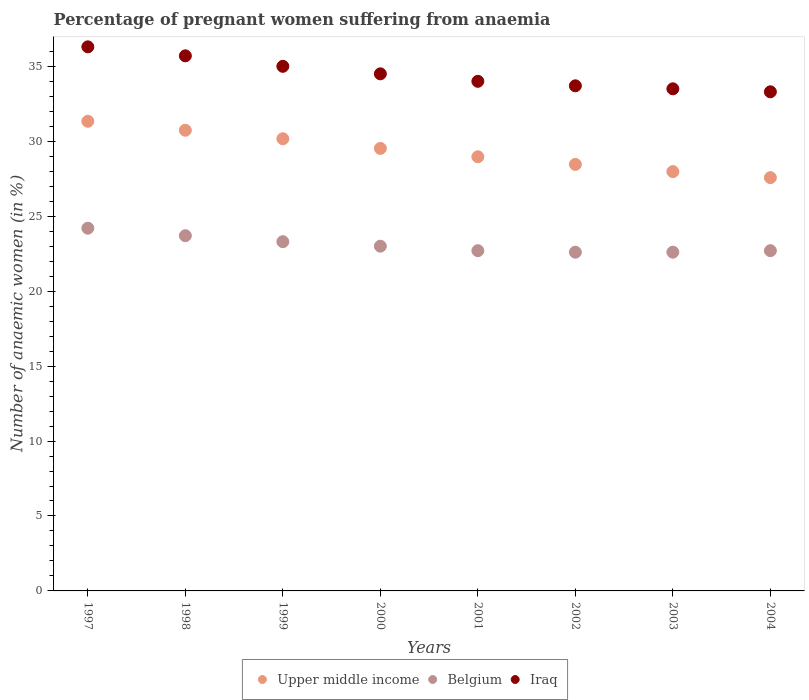How many different coloured dotlines are there?
Your response must be concise. 3. What is the number of anaemic women in Iraq in 2002?
Offer a terse response. 33.7. Across all years, what is the maximum number of anaemic women in Iraq?
Ensure brevity in your answer.  36.3. Across all years, what is the minimum number of anaemic women in Belgium?
Your answer should be very brief. 22.6. In which year was the number of anaemic women in Iraq maximum?
Make the answer very short. 1997. In which year was the number of anaemic women in Iraq minimum?
Ensure brevity in your answer.  2004. What is the total number of anaemic women in Upper middle income in the graph?
Provide a succinct answer. 234.73. What is the difference between the number of anaemic women in Belgium in 1999 and that in 2000?
Provide a short and direct response. 0.3. What is the difference between the number of anaemic women in Belgium in 2000 and the number of anaemic women in Iraq in 2001?
Your answer should be very brief. -11. What is the average number of anaemic women in Belgium per year?
Your answer should be very brief. 23.1. In how many years, is the number of anaemic women in Iraq greater than 1 %?
Keep it short and to the point. 8. What is the ratio of the number of anaemic women in Iraq in 1998 to that in 2002?
Your answer should be very brief. 1.06. Is the number of anaemic women in Iraq in 1999 less than that in 2000?
Keep it short and to the point. No. What is the difference between the highest and the second highest number of anaemic women in Iraq?
Make the answer very short. 0.6. In how many years, is the number of anaemic women in Belgium greater than the average number of anaemic women in Belgium taken over all years?
Ensure brevity in your answer.  3. Is the sum of the number of anaemic women in Upper middle income in 1997 and 1998 greater than the maximum number of anaemic women in Belgium across all years?
Offer a terse response. Yes. Does the number of anaemic women in Upper middle income monotonically increase over the years?
Keep it short and to the point. No. Is the number of anaemic women in Iraq strictly greater than the number of anaemic women in Belgium over the years?
Offer a very short reply. Yes. How many dotlines are there?
Ensure brevity in your answer.  3. Does the graph contain any zero values?
Your response must be concise. No. Does the graph contain grids?
Your answer should be compact. No. What is the title of the graph?
Your answer should be compact. Percentage of pregnant women suffering from anaemia. Does "Channel Islands" appear as one of the legend labels in the graph?
Your answer should be compact. No. What is the label or title of the Y-axis?
Offer a terse response. Number of anaemic women (in %). What is the Number of anaemic women (in %) in Upper middle income in 1997?
Offer a very short reply. 31.34. What is the Number of anaemic women (in %) of Belgium in 1997?
Offer a terse response. 24.2. What is the Number of anaemic women (in %) of Iraq in 1997?
Provide a short and direct response. 36.3. What is the Number of anaemic women (in %) in Upper middle income in 1998?
Your answer should be very brief. 30.74. What is the Number of anaemic women (in %) in Belgium in 1998?
Make the answer very short. 23.7. What is the Number of anaemic women (in %) in Iraq in 1998?
Provide a succinct answer. 35.7. What is the Number of anaemic women (in %) in Upper middle income in 1999?
Keep it short and to the point. 30.17. What is the Number of anaemic women (in %) of Belgium in 1999?
Provide a short and direct response. 23.3. What is the Number of anaemic women (in %) in Iraq in 1999?
Provide a short and direct response. 35. What is the Number of anaemic women (in %) of Upper middle income in 2000?
Provide a short and direct response. 29.52. What is the Number of anaemic women (in %) of Iraq in 2000?
Your answer should be very brief. 34.5. What is the Number of anaemic women (in %) in Upper middle income in 2001?
Provide a short and direct response. 28.97. What is the Number of anaemic women (in %) in Belgium in 2001?
Your response must be concise. 22.7. What is the Number of anaemic women (in %) in Upper middle income in 2002?
Offer a very short reply. 28.46. What is the Number of anaemic women (in %) in Belgium in 2002?
Provide a short and direct response. 22.6. What is the Number of anaemic women (in %) in Iraq in 2002?
Your answer should be very brief. 33.7. What is the Number of anaemic women (in %) of Upper middle income in 2003?
Ensure brevity in your answer.  27.98. What is the Number of anaemic women (in %) in Belgium in 2003?
Your answer should be very brief. 22.6. What is the Number of anaemic women (in %) of Iraq in 2003?
Your answer should be very brief. 33.5. What is the Number of anaemic women (in %) of Upper middle income in 2004?
Give a very brief answer. 27.57. What is the Number of anaemic women (in %) of Belgium in 2004?
Keep it short and to the point. 22.7. What is the Number of anaemic women (in %) of Iraq in 2004?
Offer a very short reply. 33.3. Across all years, what is the maximum Number of anaemic women (in %) of Upper middle income?
Keep it short and to the point. 31.34. Across all years, what is the maximum Number of anaemic women (in %) of Belgium?
Provide a short and direct response. 24.2. Across all years, what is the maximum Number of anaemic women (in %) in Iraq?
Offer a terse response. 36.3. Across all years, what is the minimum Number of anaemic women (in %) in Upper middle income?
Give a very brief answer. 27.57. Across all years, what is the minimum Number of anaemic women (in %) in Belgium?
Your answer should be very brief. 22.6. Across all years, what is the minimum Number of anaemic women (in %) in Iraq?
Your response must be concise. 33.3. What is the total Number of anaemic women (in %) in Upper middle income in the graph?
Offer a very short reply. 234.73. What is the total Number of anaemic women (in %) of Belgium in the graph?
Offer a very short reply. 184.8. What is the total Number of anaemic women (in %) of Iraq in the graph?
Your answer should be very brief. 276. What is the difference between the Number of anaemic women (in %) of Upper middle income in 1997 and that in 1998?
Your answer should be compact. 0.6. What is the difference between the Number of anaemic women (in %) in Belgium in 1997 and that in 1998?
Provide a short and direct response. 0.5. What is the difference between the Number of anaemic women (in %) in Iraq in 1997 and that in 1998?
Your answer should be compact. 0.6. What is the difference between the Number of anaemic women (in %) of Upper middle income in 1997 and that in 1999?
Provide a short and direct response. 1.17. What is the difference between the Number of anaemic women (in %) in Belgium in 1997 and that in 1999?
Your response must be concise. 0.9. What is the difference between the Number of anaemic women (in %) of Iraq in 1997 and that in 1999?
Offer a very short reply. 1.3. What is the difference between the Number of anaemic women (in %) in Upper middle income in 1997 and that in 2000?
Offer a terse response. 1.81. What is the difference between the Number of anaemic women (in %) in Upper middle income in 1997 and that in 2001?
Make the answer very short. 2.37. What is the difference between the Number of anaemic women (in %) in Upper middle income in 1997 and that in 2002?
Offer a very short reply. 2.88. What is the difference between the Number of anaemic women (in %) of Belgium in 1997 and that in 2002?
Give a very brief answer. 1.6. What is the difference between the Number of anaemic women (in %) in Iraq in 1997 and that in 2002?
Make the answer very short. 2.6. What is the difference between the Number of anaemic women (in %) in Upper middle income in 1997 and that in 2003?
Provide a succinct answer. 3.36. What is the difference between the Number of anaemic women (in %) of Belgium in 1997 and that in 2003?
Give a very brief answer. 1.6. What is the difference between the Number of anaemic women (in %) of Upper middle income in 1997 and that in 2004?
Provide a short and direct response. 3.76. What is the difference between the Number of anaemic women (in %) in Upper middle income in 1998 and that in 1999?
Your response must be concise. 0.57. What is the difference between the Number of anaemic women (in %) in Upper middle income in 1998 and that in 2000?
Provide a succinct answer. 1.21. What is the difference between the Number of anaemic women (in %) of Belgium in 1998 and that in 2000?
Your answer should be compact. 0.7. What is the difference between the Number of anaemic women (in %) in Upper middle income in 1998 and that in 2001?
Offer a very short reply. 1.77. What is the difference between the Number of anaemic women (in %) of Upper middle income in 1998 and that in 2002?
Provide a short and direct response. 2.28. What is the difference between the Number of anaemic women (in %) of Upper middle income in 1998 and that in 2003?
Offer a very short reply. 2.76. What is the difference between the Number of anaemic women (in %) in Belgium in 1998 and that in 2003?
Make the answer very short. 1.1. What is the difference between the Number of anaemic women (in %) in Iraq in 1998 and that in 2003?
Provide a succinct answer. 2.2. What is the difference between the Number of anaemic women (in %) in Upper middle income in 1998 and that in 2004?
Offer a very short reply. 3.16. What is the difference between the Number of anaemic women (in %) of Belgium in 1998 and that in 2004?
Ensure brevity in your answer.  1. What is the difference between the Number of anaemic women (in %) in Iraq in 1998 and that in 2004?
Offer a terse response. 2.4. What is the difference between the Number of anaemic women (in %) in Upper middle income in 1999 and that in 2000?
Make the answer very short. 0.64. What is the difference between the Number of anaemic women (in %) of Belgium in 1999 and that in 2000?
Your answer should be compact. 0.3. What is the difference between the Number of anaemic women (in %) in Iraq in 1999 and that in 2000?
Your answer should be compact. 0.5. What is the difference between the Number of anaemic women (in %) of Upper middle income in 1999 and that in 2001?
Your response must be concise. 1.2. What is the difference between the Number of anaemic women (in %) in Belgium in 1999 and that in 2001?
Give a very brief answer. 0.6. What is the difference between the Number of anaemic women (in %) of Iraq in 1999 and that in 2001?
Keep it short and to the point. 1. What is the difference between the Number of anaemic women (in %) of Upper middle income in 1999 and that in 2002?
Keep it short and to the point. 1.71. What is the difference between the Number of anaemic women (in %) of Belgium in 1999 and that in 2002?
Your answer should be very brief. 0.7. What is the difference between the Number of anaemic women (in %) in Iraq in 1999 and that in 2002?
Your answer should be compact. 1.3. What is the difference between the Number of anaemic women (in %) of Upper middle income in 1999 and that in 2003?
Ensure brevity in your answer.  2.19. What is the difference between the Number of anaemic women (in %) in Upper middle income in 1999 and that in 2004?
Make the answer very short. 2.59. What is the difference between the Number of anaemic women (in %) of Belgium in 1999 and that in 2004?
Your response must be concise. 0.6. What is the difference between the Number of anaemic women (in %) in Upper middle income in 2000 and that in 2001?
Provide a short and direct response. 0.56. What is the difference between the Number of anaemic women (in %) in Belgium in 2000 and that in 2001?
Provide a short and direct response. 0.3. What is the difference between the Number of anaemic women (in %) in Upper middle income in 2000 and that in 2002?
Provide a succinct answer. 1.07. What is the difference between the Number of anaemic women (in %) in Upper middle income in 2000 and that in 2003?
Give a very brief answer. 1.55. What is the difference between the Number of anaemic women (in %) in Belgium in 2000 and that in 2003?
Your answer should be compact. 0.4. What is the difference between the Number of anaemic women (in %) of Iraq in 2000 and that in 2003?
Make the answer very short. 1. What is the difference between the Number of anaemic women (in %) of Upper middle income in 2000 and that in 2004?
Your answer should be very brief. 1.95. What is the difference between the Number of anaemic women (in %) in Iraq in 2000 and that in 2004?
Give a very brief answer. 1.2. What is the difference between the Number of anaemic women (in %) of Upper middle income in 2001 and that in 2002?
Your answer should be compact. 0.51. What is the difference between the Number of anaemic women (in %) in Belgium in 2001 and that in 2002?
Give a very brief answer. 0.1. What is the difference between the Number of anaemic women (in %) in Belgium in 2001 and that in 2003?
Your answer should be very brief. 0.1. What is the difference between the Number of anaemic women (in %) in Upper middle income in 2001 and that in 2004?
Ensure brevity in your answer.  1.39. What is the difference between the Number of anaemic women (in %) of Belgium in 2001 and that in 2004?
Give a very brief answer. 0. What is the difference between the Number of anaemic women (in %) in Iraq in 2001 and that in 2004?
Provide a succinct answer. 0.7. What is the difference between the Number of anaemic women (in %) of Upper middle income in 2002 and that in 2003?
Give a very brief answer. 0.48. What is the difference between the Number of anaemic women (in %) in Belgium in 2002 and that in 2003?
Offer a terse response. 0. What is the difference between the Number of anaemic women (in %) of Upper middle income in 2002 and that in 2004?
Offer a terse response. 0.88. What is the difference between the Number of anaemic women (in %) of Upper middle income in 2003 and that in 2004?
Your response must be concise. 0.4. What is the difference between the Number of anaemic women (in %) in Belgium in 2003 and that in 2004?
Your answer should be compact. -0.1. What is the difference between the Number of anaemic women (in %) of Iraq in 2003 and that in 2004?
Give a very brief answer. 0.2. What is the difference between the Number of anaemic women (in %) of Upper middle income in 1997 and the Number of anaemic women (in %) of Belgium in 1998?
Offer a terse response. 7.64. What is the difference between the Number of anaemic women (in %) in Upper middle income in 1997 and the Number of anaemic women (in %) in Iraq in 1998?
Your response must be concise. -4.36. What is the difference between the Number of anaemic women (in %) in Belgium in 1997 and the Number of anaemic women (in %) in Iraq in 1998?
Your answer should be compact. -11.5. What is the difference between the Number of anaemic women (in %) in Upper middle income in 1997 and the Number of anaemic women (in %) in Belgium in 1999?
Your answer should be very brief. 8.04. What is the difference between the Number of anaemic women (in %) in Upper middle income in 1997 and the Number of anaemic women (in %) in Iraq in 1999?
Offer a terse response. -3.66. What is the difference between the Number of anaemic women (in %) in Belgium in 1997 and the Number of anaemic women (in %) in Iraq in 1999?
Provide a short and direct response. -10.8. What is the difference between the Number of anaemic women (in %) in Upper middle income in 1997 and the Number of anaemic women (in %) in Belgium in 2000?
Ensure brevity in your answer.  8.34. What is the difference between the Number of anaemic women (in %) of Upper middle income in 1997 and the Number of anaemic women (in %) of Iraq in 2000?
Offer a very short reply. -3.16. What is the difference between the Number of anaemic women (in %) in Upper middle income in 1997 and the Number of anaemic women (in %) in Belgium in 2001?
Your answer should be very brief. 8.64. What is the difference between the Number of anaemic women (in %) in Upper middle income in 1997 and the Number of anaemic women (in %) in Iraq in 2001?
Provide a short and direct response. -2.66. What is the difference between the Number of anaemic women (in %) of Upper middle income in 1997 and the Number of anaemic women (in %) of Belgium in 2002?
Your answer should be very brief. 8.74. What is the difference between the Number of anaemic women (in %) of Upper middle income in 1997 and the Number of anaemic women (in %) of Iraq in 2002?
Offer a terse response. -2.36. What is the difference between the Number of anaemic women (in %) in Belgium in 1997 and the Number of anaemic women (in %) in Iraq in 2002?
Provide a succinct answer. -9.5. What is the difference between the Number of anaemic women (in %) in Upper middle income in 1997 and the Number of anaemic women (in %) in Belgium in 2003?
Give a very brief answer. 8.74. What is the difference between the Number of anaemic women (in %) of Upper middle income in 1997 and the Number of anaemic women (in %) of Iraq in 2003?
Your answer should be compact. -2.16. What is the difference between the Number of anaemic women (in %) of Upper middle income in 1997 and the Number of anaemic women (in %) of Belgium in 2004?
Keep it short and to the point. 8.64. What is the difference between the Number of anaemic women (in %) of Upper middle income in 1997 and the Number of anaemic women (in %) of Iraq in 2004?
Provide a short and direct response. -1.96. What is the difference between the Number of anaemic women (in %) of Belgium in 1997 and the Number of anaemic women (in %) of Iraq in 2004?
Provide a short and direct response. -9.1. What is the difference between the Number of anaemic women (in %) of Upper middle income in 1998 and the Number of anaemic women (in %) of Belgium in 1999?
Offer a very short reply. 7.44. What is the difference between the Number of anaemic women (in %) of Upper middle income in 1998 and the Number of anaemic women (in %) of Iraq in 1999?
Your response must be concise. -4.26. What is the difference between the Number of anaemic women (in %) in Belgium in 1998 and the Number of anaemic women (in %) in Iraq in 1999?
Keep it short and to the point. -11.3. What is the difference between the Number of anaemic women (in %) of Upper middle income in 1998 and the Number of anaemic women (in %) of Belgium in 2000?
Ensure brevity in your answer.  7.74. What is the difference between the Number of anaemic women (in %) of Upper middle income in 1998 and the Number of anaemic women (in %) of Iraq in 2000?
Your response must be concise. -3.76. What is the difference between the Number of anaemic women (in %) in Belgium in 1998 and the Number of anaemic women (in %) in Iraq in 2000?
Your answer should be compact. -10.8. What is the difference between the Number of anaemic women (in %) of Upper middle income in 1998 and the Number of anaemic women (in %) of Belgium in 2001?
Offer a terse response. 8.04. What is the difference between the Number of anaemic women (in %) in Upper middle income in 1998 and the Number of anaemic women (in %) in Iraq in 2001?
Your answer should be compact. -3.26. What is the difference between the Number of anaemic women (in %) in Belgium in 1998 and the Number of anaemic women (in %) in Iraq in 2001?
Keep it short and to the point. -10.3. What is the difference between the Number of anaemic women (in %) of Upper middle income in 1998 and the Number of anaemic women (in %) of Belgium in 2002?
Your answer should be very brief. 8.14. What is the difference between the Number of anaemic women (in %) in Upper middle income in 1998 and the Number of anaemic women (in %) in Iraq in 2002?
Your response must be concise. -2.96. What is the difference between the Number of anaemic women (in %) of Upper middle income in 1998 and the Number of anaemic women (in %) of Belgium in 2003?
Give a very brief answer. 8.14. What is the difference between the Number of anaemic women (in %) of Upper middle income in 1998 and the Number of anaemic women (in %) of Iraq in 2003?
Provide a succinct answer. -2.76. What is the difference between the Number of anaemic women (in %) in Belgium in 1998 and the Number of anaemic women (in %) in Iraq in 2003?
Your response must be concise. -9.8. What is the difference between the Number of anaemic women (in %) in Upper middle income in 1998 and the Number of anaemic women (in %) in Belgium in 2004?
Ensure brevity in your answer.  8.04. What is the difference between the Number of anaemic women (in %) of Upper middle income in 1998 and the Number of anaemic women (in %) of Iraq in 2004?
Offer a very short reply. -2.56. What is the difference between the Number of anaemic women (in %) of Belgium in 1998 and the Number of anaemic women (in %) of Iraq in 2004?
Provide a succinct answer. -9.6. What is the difference between the Number of anaemic women (in %) of Upper middle income in 1999 and the Number of anaemic women (in %) of Belgium in 2000?
Your answer should be compact. 7.17. What is the difference between the Number of anaemic women (in %) in Upper middle income in 1999 and the Number of anaemic women (in %) in Iraq in 2000?
Provide a short and direct response. -4.33. What is the difference between the Number of anaemic women (in %) in Upper middle income in 1999 and the Number of anaemic women (in %) in Belgium in 2001?
Your answer should be very brief. 7.47. What is the difference between the Number of anaemic women (in %) of Upper middle income in 1999 and the Number of anaemic women (in %) of Iraq in 2001?
Give a very brief answer. -3.83. What is the difference between the Number of anaemic women (in %) in Belgium in 1999 and the Number of anaemic women (in %) in Iraq in 2001?
Keep it short and to the point. -10.7. What is the difference between the Number of anaemic women (in %) in Upper middle income in 1999 and the Number of anaemic women (in %) in Belgium in 2002?
Make the answer very short. 7.57. What is the difference between the Number of anaemic women (in %) in Upper middle income in 1999 and the Number of anaemic women (in %) in Iraq in 2002?
Offer a very short reply. -3.53. What is the difference between the Number of anaemic women (in %) in Belgium in 1999 and the Number of anaemic women (in %) in Iraq in 2002?
Your answer should be very brief. -10.4. What is the difference between the Number of anaemic women (in %) of Upper middle income in 1999 and the Number of anaemic women (in %) of Belgium in 2003?
Make the answer very short. 7.57. What is the difference between the Number of anaemic women (in %) in Upper middle income in 1999 and the Number of anaemic women (in %) in Iraq in 2003?
Keep it short and to the point. -3.33. What is the difference between the Number of anaemic women (in %) in Belgium in 1999 and the Number of anaemic women (in %) in Iraq in 2003?
Make the answer very short. -10.2. What is the difference between the Number of anaemic women (in %) of Upper middle income in 1999 and the Number of anaemic women (in %) of Belgium in 2004?
Give a very brief answer. 7.47. What is the difference between the Number of anaemic women (in %) in Upper middle income in 1999 and the Number of anaemic women (in %) in Iraq in 2004?
Ensure brevity in your answer.  -3.13. What is the difference between the Number of anaemic women (in %) of Upper middle income in 2000 and the Number of anaemic women (in %) of Belgium in 2001?
Ensure brevity in your answer.  6.82. What is the difference between the Number of anaemic women (in %) in Upper middle income in 2000 and the Number of anaemic women (in %) in Iraq in 2001?
Give a very brief answer. -4.48. What is the difference between the Number of anaemic women (in %) in Belgium in 2000 and the Number of anaemic women (in %) in Iraq in 2001?
Offer a very short reply. -11. What is the difference between the Number of anaemic women (in %) of Upper middle income in 2000 and the Number of anaemic women (in %) of Belgium in 2002?
Provide a succinct answer. 6.92. What is the difference between the Number of anaemic women (in %) in Upper middle income in 2000 and the Number of anaemic women (in %) in Iraq in 2002?
Offer a very short reply. -4.18. What is the difference between the Number of anaemic women (in %) of Belgium in 2000 and the Number of anaemic women (in %) of Iraq in 2002?
Your response must be concise. -10.7. What is the difference between the Number of anaemic women (in %) of Upper middle income in 2000 and the Number of anaemic women (in %) of Belgium in 2003?
Offer a terse response. 6.92. What is the difference between the Number of anaemic women (in %) in Upper middle income in 2000 and the Number of anaemic women (in %) in Iraq in 2003?
Provide a succinct answer. -3.98. What is the difference between the Number of anaemic women (in %) in Belgium in 2000 and the Number of anaemic women (in %) in Iraq in 2003?
Ensure brevity in your answer.  -10.5. What is the difference between the Number of anaemic women (in %) in Upper middle income in 2000 and the Number of anaemic women (in %) in Belgium in 2004?
Provide a succinct answer. 6.82. What is the difference between the Number of anaemic women (in %) of Upper middle income in 2000 and the Number of anaemic women (in %) of Iraq in 2004?
Make the answer very short. -3.78. What is the difference between the Number of anaemic women (in %) in Upper middle income in 2001 and the Number of anaemic women (in %) in Belgium in 2002?
Offer a very short reply. 6.37. What is the difference between the Number of anaemic women (in %) in Upper middle income in 2001 and the Number of anaemic women (in %) in Iraq in 2002?
Your answer should be very brief. -4.73. What is the difference between the Number of anaemic women (in %) of Upper middle income in 2001 and the Number of anaemic women (in %) of Belgium in 2003?
Give a very brief answer. 6.37. What is the difference between the Number of anaemic women (in %) of Upper middle income in 2001 and the Number of anaemic women (in %) of Iraq in 2003?
Your answer should be very brief. -4.53. What is the difference between the Number of anaemic women (in %) of Upper middle income in 2001 and the Number of anaemic women (in %) of Belgium in 2004?
Offer a terse response. 6.27. What is the difference between the Number of anaemic women (in %) of Upper middle income in 2001 and the Number of anaemic women (in %) of Iraq in 2004?
Your answer should be compact. -4.33. What is the difference between the Number of anaemic women (in %) in Upper middle income in 2002 and the Number of anaemic women (in %) in Belgium in 2003?
Keep it short and to the point. 5.86. What is the difference between the Number of anaemic women (in %) in Upper middle income in 2002 and the Number of anaemic women (in %) in Iraq in 2003?
Your answer should be very brief. -5.04. What is the difference between the Number of anaemic women (in %) in Belgium in 2002 and the Number of anaemic women (in %) in Iraq in 2003?
Your answer should be very brief. -10.9. What is the difference between the Number of anaemic women (in %) in Upper middle income in 2002 and the Number of anaemic women (in %) in Belgium in 2004?
Give a very brief answer. 5.76. What is the difference between the Number of anaemic women (in %) in Upper middle income in 2002 and the Number of anaemic women (in %) in Iraq in 2004?
Provide a short and direct response. -4.84. What is the difference between the Number of anaemic women (in %) in Belgium in 2002 and the Number of anaemic women (in %) in Iraq in 2004?
Make the answer very short. -10.7. What is the difference between the Number of anaemic women (in %) in Upper middle income in 2003 and the Number of anaemic women (in %) in Belgium in 2004?
Ensure brevity in your answer.  5.28. What is the difference between the Number of anaemic women (in %) of Upper middle income in 2003 and the Number of anaemic women (in %) of Iraq in 2004?
Give a very brief answer. -5.32. What is the average Number of anaemic women (in %) in Upper middle income per year?
Ensure brevity in your answer.  29.34. What is the average Number of anaemic women (in %) in Belgium per year?
Your answer should be very brief. 23.1. What is the average Number of anaemic women (in %) of Iraq per year?
Keep it short and to the point. 34.5. In the year 1997, what is the difference between the Number of anaemic women (in %) in Upper middle income and Number of anaemic women (in %) in Belgium?
Provide a short and direct response. 7.14. In the year 1997, what is the difference between the Number of anaemic women (in %) in Upper middle income and Number of anaemic women (in %) in Iraq?
Give a very brief answer. -4.96. In the year 1997, what is the difference between the Number of anaemic women (in %) in Belgium and Number of anaemic women (in %) in Iraq?
Your response must be concise. -12.1. In the year 1998, what is the difference between the Number of anaemic women (in %) of Upper middle income and Number of anaemic women (in %) of Belgium?
Keep it short and to the point. 7.04. In the year 1998, what is the difference between the Number of anaemic women (in %) in Upper middle income and Number of anaemic women (in %) in Iraq?
Ensure brevity in your answer.  -4.96. In the year 1998, what is the difference between the Number of anaemic women (in %) of Belgium and Number of anaemic women (in %) of Iraq?
Make the answer very short. -12. In the year 1999, what is the difference between the Number of anaemic women (in %) in Upper middle income and Number of anaemic women (in %) in Belgium?
Give a very brief answer. 6.87. In the year 1999, what is the difference between the Number of anaemic women (in %) in Upper middle income and Number of anaemic women (in %) in Iraq?
Offer a very short reply. -4.83. In the year 2000, what is the difference between the Number of anaemic women (in %) in Upper middle income and Number of anaemic women (in %) in Belgium?
Your response must be concise. 6.52. In the year 2000, what is the difference between the Number of anaemic women (in %) of Upper middle income and Number of anaemic women (in %) of Iraq?
Give a very brief answer. -4.98. In the year 2001, what is the difference between the Number of anaemic women (in %) in Upper middle income and Number of anaemic women (in %) in Belgium?
Make the answer very short. 6.27. In the year 2001, what is the difference between the Number of anaemic women (in %) of Upper middle income and Number of anaemic women (in %) of Iraq?
Keep it short and to the point. -5.03. In the year 2002, what is the difference between the Number of anaemic women (in %) of Upper middle income and Number of anaemic women (in %) of Belgium?
Provide a short and direct response. 5.86. In the year 2002, what is the difference between the Number of anaemic women (in %) of Upper middle income and Number of anaemic women (in %) of Iraq?
Give a very brief answer. -5.24. In the year 2003, what is the difference between the Number of anaemic women (in %) in Upper middle income and Number of anaemic women (in %) in Belgium?
Give a very brief answer. 5.38. In the year 2003, what is the difference between the Number of anaemic women (in %) in Upper middle income and Number of anaemic women (in %) in Iraq?
Give a very brief answer. -5.52. In the year 2004, what is the difference between the Number of anaemic women (in %) of Upper middle income and Number of anaemic women (in %) of Belgium?
Your response must be concise. 4.87. In the year 2004, what is the difference between the Number of anaemic women (in %) of Upper middle income and Number of anaemic women (in %) of Iraq?
Your response must be concise. -5.73. What is the ratio of the Number of anaemic women (in %) of Upper middle income in 1997 to that in 1998?
Give a very brief answer. 1.02. What is the ratio of the Number of anaemic women (in %) in Belgium in 1997 to that in 1998?
Make the answer very short. 1.02. What is the ratio of the Number of anaemic women (in %) of Iraq in 1997 to that in 1998?
Your response must be concise. 1.02. What is the ratio of the Number of anaemic women (in %) in Upper middle income in 1997 to that in 1999?
Your response must be concise. 1.04. What is the ratio of the Number of anaemic women (in %) of Belgium in 1997 to that in 1999?
Provide a short and direct response. 1.04. What is the ratio of the Number of anaemic women (in %) in Iraq in 1997 to that in 1999?
Give a very brief answer. 1.04. What is the ratio of the Number of anaemic women (in %) of Upper middle income in 1997 to that in 2000?
Your response must be concise. 1.06. What is the ratio of the Number of anaemic women (in %) of Belgium in 1997 to that in 2000?
Your answer should be very brief. 1.05. What is the ratio of the Number of anaemic women (in %) in Iraq in 1997 to that in 2000?
Offer a very short reply. 1.05. What is the ratio of the Number of anaemic women (in %) of Upper middle income in 1997 to that in 2001?
Give a very brief answer. 1.08. What is the ratio of the Number of anaemic women (in %) in Belgium in 1997 to that in 2001?
Your answer should be very brief. 1.07. What is the ratio of the Number of anaemic women (in %) of Iraq in 1997 to that in 2001?
Your answer should be very brief. 1.07. What is the ratio of the Number of anaemic women (in %) of Upper middle income in 1997 to that in 2002?
Your answer should be compact. 1.1. What is the ratio of the Number of anaemic women (in %) of Belgium in 1997 to that in 2002?
Keep it short and to the point. 1.07. What is the ratio of the Number of anaemic women (in %) of Iraq in 1997 to that in 2002?
Ensure brevity in your answer.  1.08. What is the ratio of the Number of anaemic women (in %) in Upper middle income in 1997 to that in 2003?
Your response must be concise. 1.12. What is the ratio of the Number of anaemic women (in %) in Belgium in 1997 to that in 2003?
Provide a short and direct response. 1.07. What is the ratio of the Number of anaemic women (in %) in Iraq in 1997 to that in 2003?
Ensure brevity in your answer.  1.08. What is the ratio of the Number of anaemic women (in %) in Upper middle income in 1997 to that in 2004?
Keep it short and to the point. 1.14. What is the ratio of the Number of anaemic women (in %) in Belgium in 1997 to that in 2004?
Provide a succinct answer. 1.07. What is the ratio of the Number of anaemic women (in %) of Iraq in 1997 to that in 2004?
Provide a succinct answer. 1.09. What is the ratio of the Number of anaemic women (in %) of Upper middle income in 1998 to that in 1999?
Provide a succinct answer. 1.02. What is the ratio of the Number of anaemic women (in %) of Belgium in 1998 to that in 1999?
Offer a terse response. 1.02. What is the ratio of the Number of anaemic women (in %) in Iraq in 1998 to that in 1999?
Offer a terse response. 1.02. What is the ratio of the Number of anaemic women (in %) of Upper middle income in 1998 to that in 2000?
Your response must be concise. 1.04. What is the ratio of the Number of anaemic women (in %) in Belgium in 1998 to that in 2000?
Offer a very short reply. 1.03. What is the ratio of the Number of anaemic women (in %) in Iraq in 1998 to that in 2000?
Provide a short and direct response. 1.03. What is the ratio of the Number of anaemic women (in %) in Upper middle income in 1998 to that in 2001?
Ensure brevity in your answer.  1.06. What is the ratio of the Number of anaemic women (in %) of Belgium in 1998 to that in 2001?
Keep it short and to the point. 1.04. What is the ratio of the Number of anaemic women (in %) in Iraq in 1998 to that in 2001?
Keep it short and to the point. 1.05. What is the ratio of the Number of anaemic women (in %) of Upper middle income in 1998 to that in 2002?
Your answer should be compact. 1.08. What is the ratio of the Number of anaemic women (in %) in Belgium in 1998 to that in 2002?
Provide a short and direct response. 1.05. What is the ratio of the Number of anaemic women (in %) of Iraq in 1998 to that in 2002?
Make the answer very short. 1.06. What is the ratio of the Number of anaemic women (in %) in Upper middle income in 1998 to that in 2003?
Your answer should be compact. 1.1. What is the ratio of the Number of anaemic women (in %) in Belgium in 1998 to that in 2003?
Provide a short and direct response. 1.05. What is the ratio of the Number of anaemic women (in %) in Iraq in 1998 to that in 2003?
Offer a terse response. 1.07. What is the ratio of the Number of anaemic women (in %) in Upper middle income in 1998 to that in 2004?
Offer a very short reply. 1.11. What is the ratio of the Number of anaemic women (in %) in Belgium in 1998 to that in 2004?
Offer a very short reply. 1.04. What is the ratio of the Number of anaemic women (in %) in Iraq in 1998 to that in 2004?
Keep it short and to the point. 1.07. What is the ratio of the Number of anaemic women (in %) in Upper middle income in 1999 to that in 2000?
Offer a very short reply. 1.02. What is the ratio of the Number of anaemic women (in %) in Belgium in 1999 to that in 2000?
Ensure brevity in your answer.  1.01. What is the ratio of the Number of anaemic women (in %) of Iraq in 1999 to that in 2000?
Provide a succinct answer. 1.01. What is the ratio of the Number of anaemic women (in %) of Upper middle income in 1999 to that in 2001?
Provide a succinct answer. 1.04. What is the ratio of the Number of anaemic women (in %) of Belgium in 1999 to that in 2001?
Give a very brief answer. 1.03. What is the ratio of the Number of anaemic women (in %) in Iraq in 1999 to that in 2001?
Make the answer very short. 1.03. What is the ratio of the Number of anaemic women (in %) of Upper middle income in 1999 to that in 2002?
Ensure brevity in your answer.  1.06. What is the ratio of the Number of anaemic women (in %) in Belgium in 1999 to that in 2002?
Your answer should be compact. 1.03. What is the ratio of the Number of anaemic women (in %) in Iraq in 1999 to that in 2002?
Give a very brief answer. 1.04. What is the ratio of the Number of anaemic women (in %) of Upper middle income in 1999 to that in 2003?
Make the answer very short. 1.08. What is the ratio of the Number of anaemic women (in %) in Belgium in 1999 to that in 2003?
Offer a terse response. 1.03. What is the ratio of the Number of anaemic women (in %) of Iraq in 1999 to that in 2003?
Your answer should be very brief. 1.04. What is the ratio of the Number of anaemic women (in %) in Upper middle income in 1999 to that in 2004?
Your answer should be compact. 1.09. What is the ratio of the Number of anaemic women (in %) in Belgium in 1999 to that in 2004?
Your answer should be compact. 1.03. What is the ratio of the Number of anaemic women (in %) in Iraq in 1999 to that in 2004?
Offer a terse response. 1.05. What is the ratio of the Number of anaemic women (in %) in Upper middle income in 2000 to that in 2001?
Make the answer very short. 1.02. What is the ratio of the Number of anaemic women (in %) of Belgium in 2000 to that in 2001?
Ensure brevity in your answer.  1.01. What is the ratio of the Number of anaemic women (in %) in Iraq in 2000 to that in 2001?
Give a very brief answer. 1.01. What is the ratio of the Number of anaemic women (in %) in Upper middle income in 2000 to that in 2002?
Make the answer very short. 1.04. What is the ratio of the Number of anaemic women (in %) of Belgium in 2000 to that in 2002?
Ensure brevity in your answer.  1.02. What is the ratio of the Number of anaemic women (in %) in Iraq in 2000 to that in 2002?
Provide a succinct answer. 1.02. What is the ratio of the Number of anaemic women (in %) in Upper middle income in 2000 to that in 2003?
Your answer should be very brief. 1.06. What is the ratio of the Number of anaemic women (in %) in Belgium in 2000 to that in 2003?
Your answer should be very brief. 1.02. What is the ratio of the Number of anaemic women (in %) in Iraq in 2000 to that in 2003?
Your response must be concise. 1.03. What is the ratio of the Number of anaemic women (in %) in Upper middle income in 2000 to that in 2004?
Your answer should be compact. 1.07. What is the ratio of the Number of anaemic women (in %) of Belgium in 2000 to that in 2004?
Provide a succinct answer. 1.01. What is the ratio of the Number of anaemic women (in %) in Iraq in 2000 to that in 2004?
Make the answer very short. 1.04. What is the ratio of the Number of anaemic women (in %) of Upper middle income in 2001 to that in 2002?
Provide a short and direct response. 1.02. What is the ratio of the Number of anaemic women (in %) of Belgium in 2001 to that in 2002?
Ensure brevity in your answer.  1. What is the ratio of the Number of anaemic women (in %) of Iraq in 2001 to that in 2002?
Make the answer very short. 1.01. What is the ratio of the Number of anaemic women (in %) of Upper middle income in 2001 to that in 2003?
Keep it short and to the point. 1.04. What is the ratio of the Number of anaemic women (in %) in Belgium in 2001 to that in 2003?
Your response must be concise. 1. What is the ratio of the Number of anaemic women (in %) in Iraq in 2001 to that in 2003?
Your answer should be very brief. 1.01. What is the ratio of the Number of anaemic women (in %) of Upper middle income in 2001 to that in 2004?
Keep it short and to the point. 1.05. What is the ratio of the Number of anaemic women (in %) of Belgium in 2001 to that in 2004?
Provide a succinct answer. 1. What is the ratio of the Number of anaemic women (in %) of Upper middle income in 2002 to that in 2003?
Give a very brief answer. 1.02. What is the ratio of the Number of anaemic women (in %) in Upper middle income in 2002 to that in 2004?
Ensure brevity in your answer.  1.03. What is the ratio of the Number of anaemic women (in %) in Iraq in 2002 to that in 2004?
Ensure brevity in your answer.  1.01. What is the ratio of the Number of anaemic women (in %) of Upper middle income in 2003 to that in 2004?
Provide a succinct answer. 1.01. What is the ratio of the Number of anaemic women (in %) in Belgium in 2003 to that in 2004?
Give a very brief answer. 1. What is the difference between the highest and the second highest Number of anaemic women (in %) of Upper middle income?
Your answer should be compact. 0.6. What is the difference between the highest and the second highest Number of anaemic women (in %) in Belgium?
Offer a terse response. 0.5. What is the difference between the highest and the lowest Number of anaemic women (in %) in Upper middle income?
Keep it short and to the point. 3.76. What is the difference between the highest and the lowest Number of anaemic women (in %) of Belgium?
Ensure brevity in your answer.  1.6. What is the difference between the highest and the lowest Number of anaemic women (in %) of Iraq?
Offer a terse response. 3. 